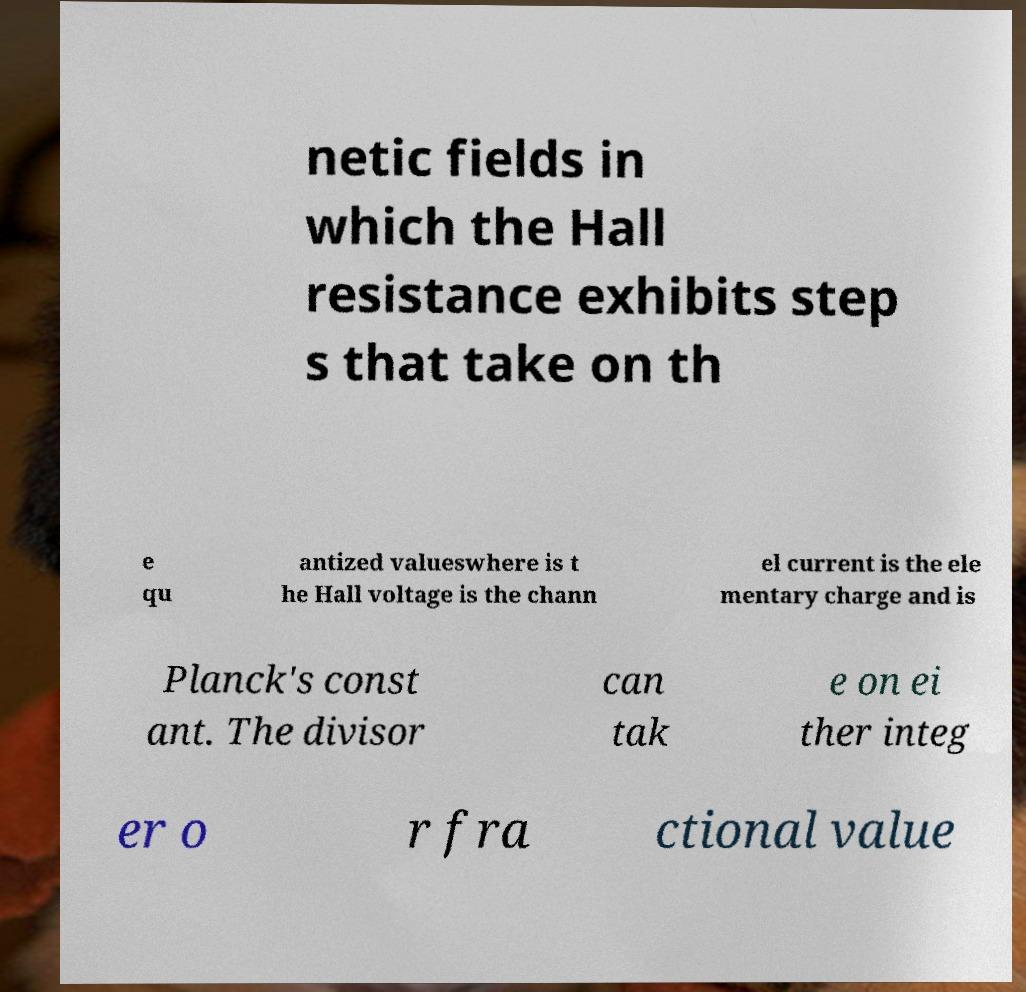Could you assist in decoding the text presented in this image and type it out clearly? netic fields in which the Hall resistance exhibits step s that take on th e qu antized valueswhere is t he Hall voltage is the chann el current is the ele mentary charge and is Planck's const ant. The divisor can tak e on ei ther integ er o r fra ctional value 